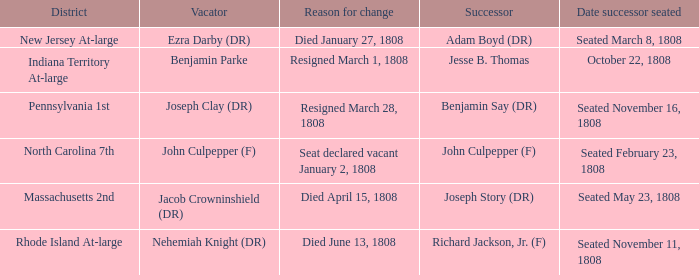Who is the successor when the reason for change is seat declared vacant January 2, 1808 John Culpepper (F). 